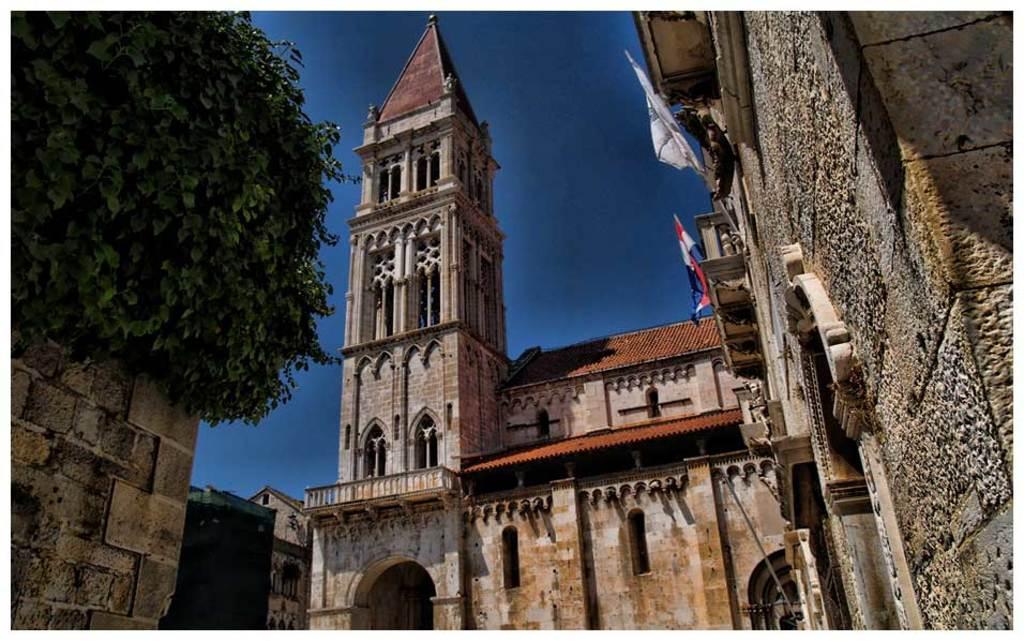Please provide a concise description of this image. In this image, there are a few buildings. We can see a tree on the left. We can see some flags on one of the buildings. We can also see the sky and a green colored object. 